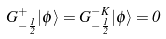<formula> <loc_0><loc_0><loc_500><loc_500>G ^ { + } _ { - \frac { 1 } { 2 } } | \phi \rangle = G ^ { - K } _ { - \frac { 1 } { 2 } } | \phi \rangle = 0</formula> 